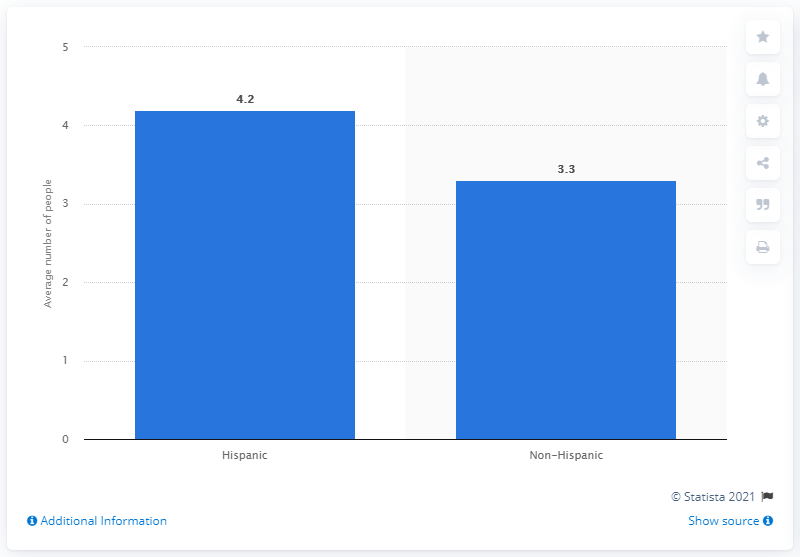Indicate a few pertinent items in this graphic. In March 2014, the average size of Hispanic parties visiting Chiropractic Reporting, Inc. (CDRs) was 4.2. 